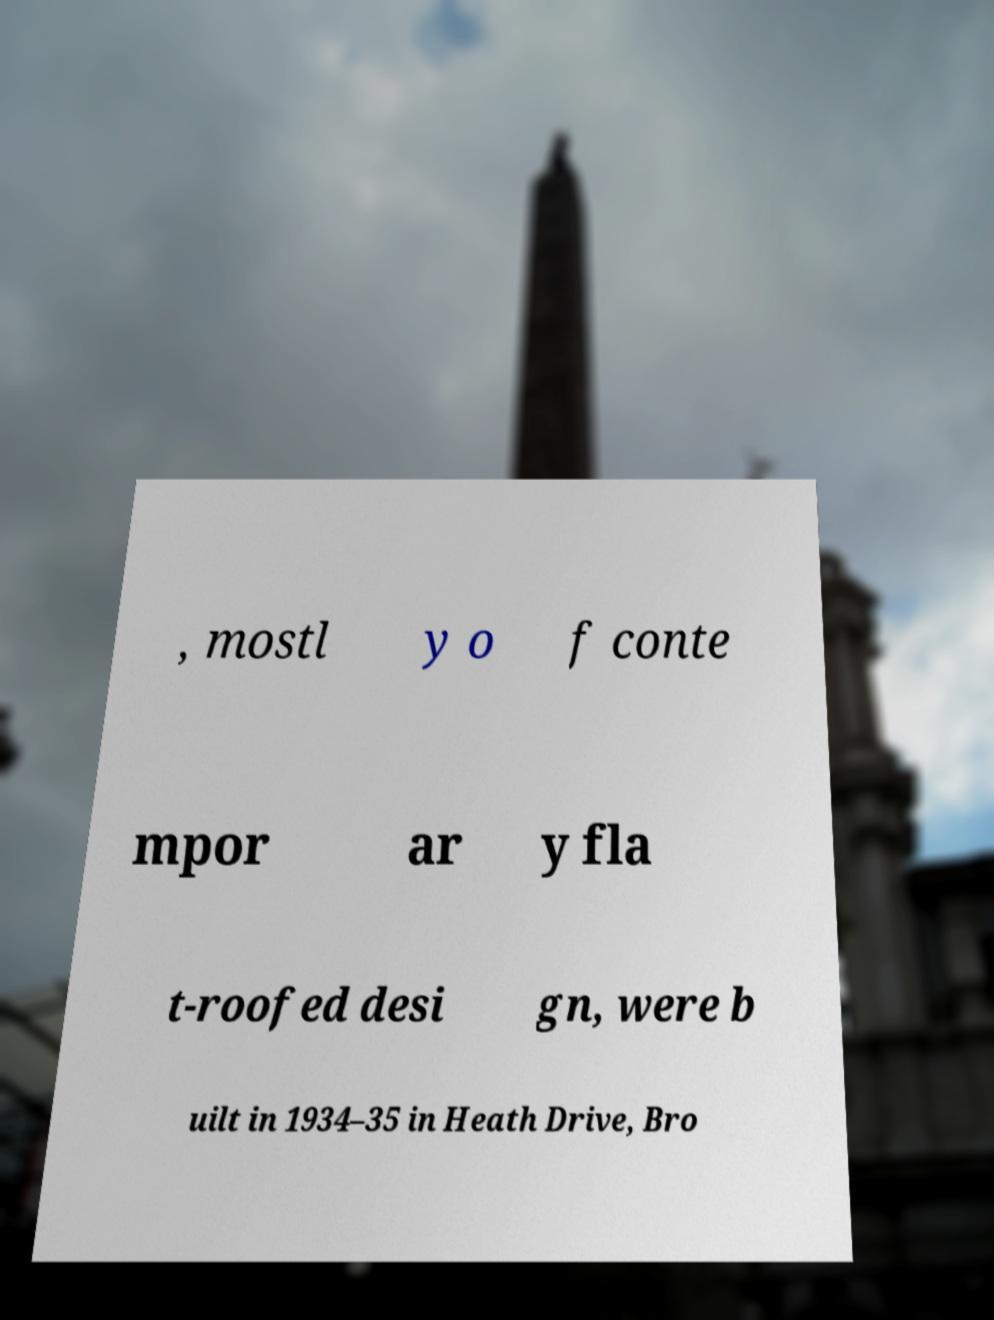Please read and relay the text visible in this image. What does it say? , mostl y o f conte mpor ar y fla t-roofed desi gn, were b uilt in 1934–35 in Heath Drive, Bro 